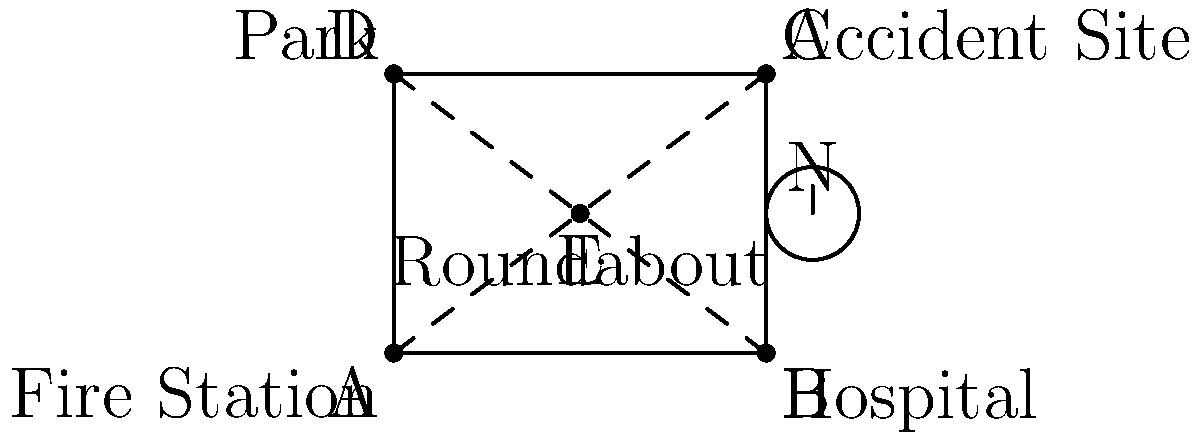As a nurse volunteering at the fire station, you receive an emergency call about an accident at point C. Given the map, which route would you recommend to the ambulance driver for the quickest path from the Fire Station (A) to the Accident Site (C)? To determine the quickest path, we need to analyze the available routes:

1. Route A-E-C: This route goes through the Roundabout (E).
2. Route A-B-C: This route goes along the bottom and right sides of the map.

To compare these routes:

1. Route A-E-C:
   - Distance A to E: $\sqrt{2^2 + 1.5^2} = \sqrt{6.25} \approx 2.5$ units
   - Distance E to C: $\sqrt{2^2 + 1.5^2} = \sqrt{6.25} \approx 2.5$ units
   - Total distance: $2.5 + 2.5 = 5$ units

2. Route A-B-C:
   - Distance A to B: 4 units
   - Distance B to C: 3 units
   - Total distance: $4 + 3 = 7$ units

The route A-E-C is shorter (5 units vs 7 units). Additionally, going through the Roundabout (E) might be faster than making a 90-degree turn at point B.

Considering both distance and ease of navigation, the quickest path from the Fire Station (A) to the Accident Site (C) is likely the route A-E-C, passing through the Roundabout (E).
Answer: A-E-C (through the Roundabout) 